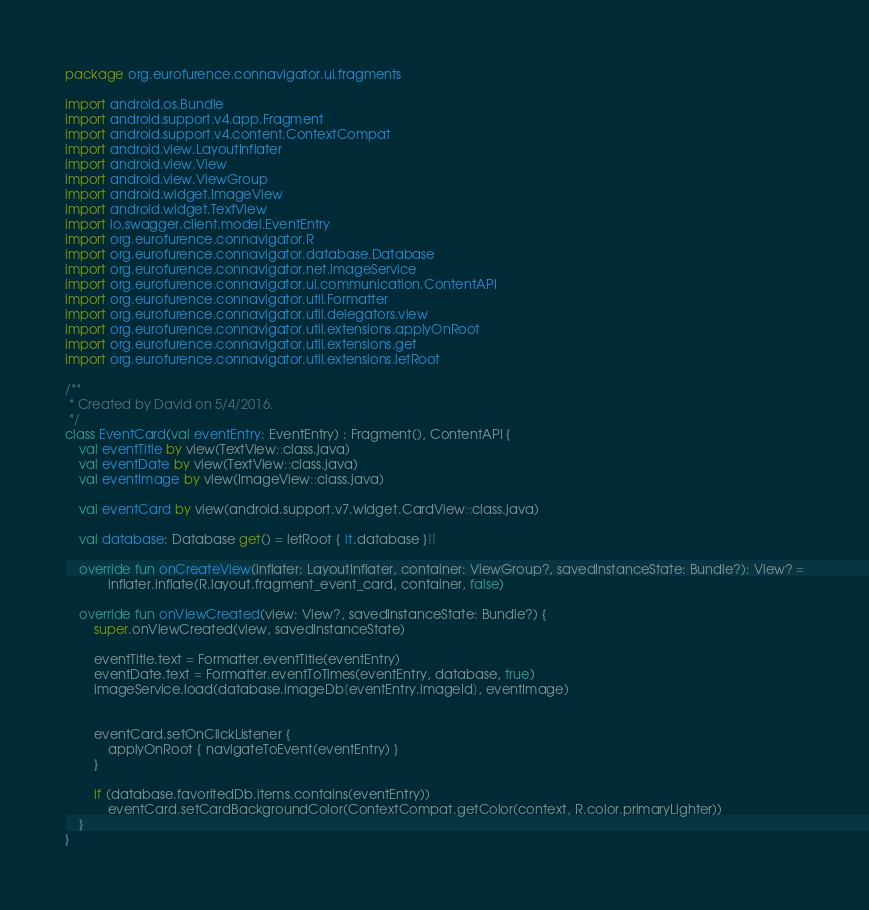Convert code to text. <code><loc_0><loc_0><loc_500><loc_500><_Kotlin_>package org.eurofurence.connavigator.ui.fragments

import android.os.Bundle
import android.support.v4.app.Fragment
import android.support.v4.content.ContextCompat
import android.view.LayoutInflater
import android.view.View
import android.view.ViewGroup
import android.widget.ImageView
import android.widget.TextView
import io.swagger.client.model.EventEntry
import org.eurofurence.connavigator.R
import org.eurofurence.connavigator.database.Database
import org.eurofurence.connavigator.net.imageService
import org.eurofurence.connavigator.ui.communication.ContentAPI
import org.eurofurence.connavigator.util.Formatter
import org.eurofurence.connavigator.util.delegators.view
import org.eurofurence.connavigator.util.extensions.applyOnRoot
import org.eurofurence.connavigator.util.extensions.get
import org.eurofurence.connavigator.util.extensions.letRoot

/**
 * Created by David on 5/4/2016.
 */
class EventCard(val eventEntry: EventEntry) : Fragment(), ContentAPI {
    val eventTitle by view(TextView::class.java)
    val eventDate by view(TextView::class.java)
    val eventImage by view(ImageView::class.java)

    val eventCard by view(android.support.v7.widget.CardView::class.java)

    val database: Database get() = letRoot { it.database }!!

    override fun onCreateView(inflater: LayoutInflater, container: ViewGroup?, savedInstanceState: Bundle?): View? =
            inflater.inflate(R.layout.fragment_event_card, container, false)

    override fun onViewCreated(view: View?, savedInstanceState: Bundle?) {
        super.onViewCreated(view, savedInstanceState)

        eventTitle.text = Formatter.eventTitle(eventEntry)
        eventDate.text = Formatter.eventToTimes(eventEntry, database, true)
        imageService.load(database.imageDb[eventEntry.imageId], eventImage)


        eventCard.setOnClickListener {
            applyOnRoot { navigateToEvent(eventEntry) }
        }

        if (database.favoritedDb.items.contains(eventEntry))
            eventCard.setCardBackgroundColor(ContextCompat.getColor(context, R.color.primaryLighter))
    }
}</code> 